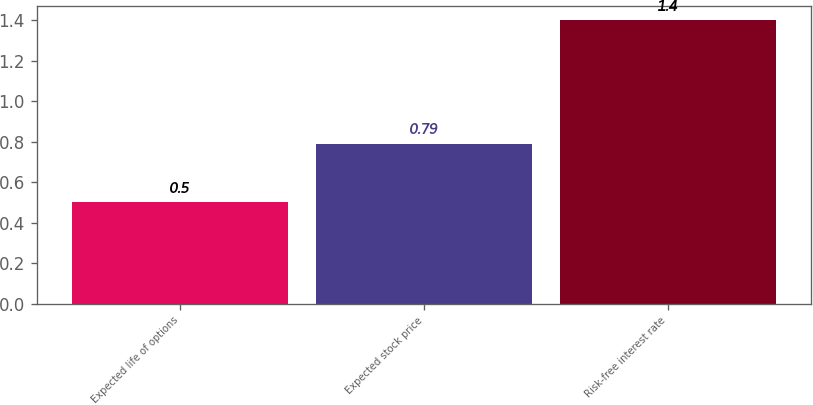Convert chart. <chart><loc_0><loc_0><loc_500><loc_500><bar_chart><fcel>Expected life of options<fcel>Expected stock price<fcel>Risk-free interest rate<nl><fcel>0.5<fcel>0.79<fcel>1.4<nl></chart> 